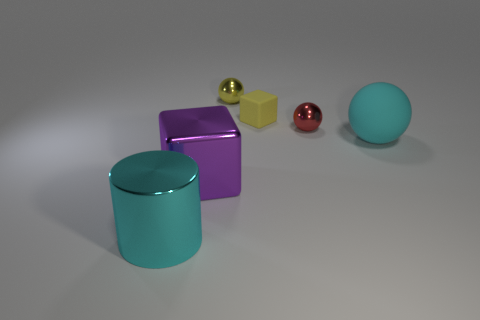What shape is the matte object that is to the left of the large cyan object on the right side of the big cyan thing left of the cyan matte ball?
Provide a succinct answer. Cube. There is a large object that is on the left side of the big cyan matte sphere and on the right side of the big cyan cylinder; what is its material?
Your answer should be compact. Metal. What color is the large thing behind the cube that is in front of the big cyan object to the right of the purple object?
Make the answer very short. Cyan. What number of yellow things are either small shiny balls or tiny matte objects?
Keep it short and to the point. 2. What number of other objects are there of the same size as the rubber cube?
Your answer should be compact. 2. What number of big cyan objects are there?
Provide a succinct answer. 2. Are there any other things that are the same shape as the big cyan metal object?
Your response must be concise. No. Is the material of the thing that is on the right side of the small red sphere the same as the cube behind the red metallic ball?
Your response must be concise. Yes. What is the material of the large purple block?
Give a very brief answer. Metal. What number of purple objects are made of the same material as the small yellow cube?
Make the answer very short. 0. 